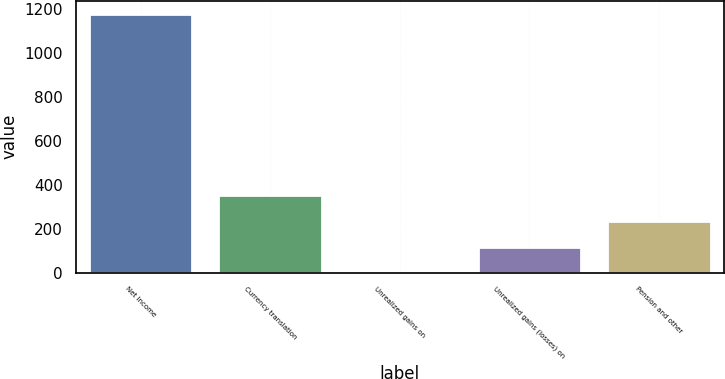Convert chart to OTSL. <chart><loc_0><loc_0><loc_500><loc_500><bar_chart><fcel>Net Income<fcel>Currency translation<fcel>Unrealized gains on<fcel>Unrealized gains (losses) on<fcel>Pension and other<nl><fcel>1177.9<fcel>353.86<fcel>0.7<fcel>118.42<fcel>236.14<nl></chart> 